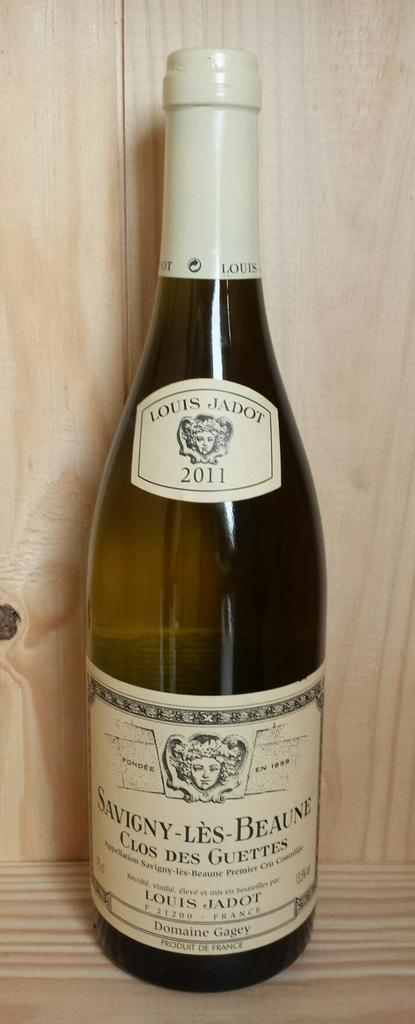Provide a one-sentence caption for the provided image. A glass of wine with French writing on the front of it. 